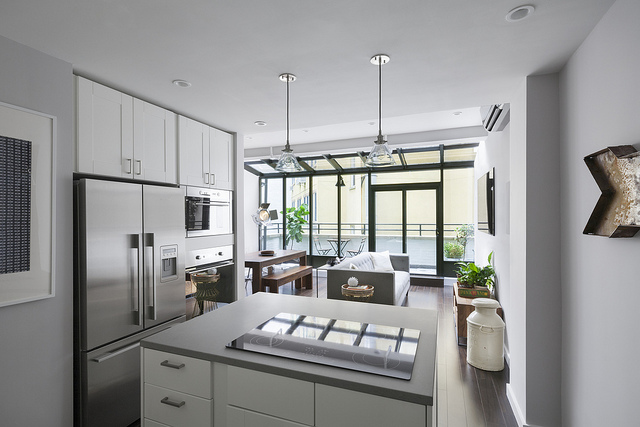<image>Was this picture taken in the last 5 years? It is unknown if this picture was taken in the last 5 years. Was this picture taken in the last 5 years? I don't know if this picture was taken in the last 5 years. It can be both yes or unknown. 